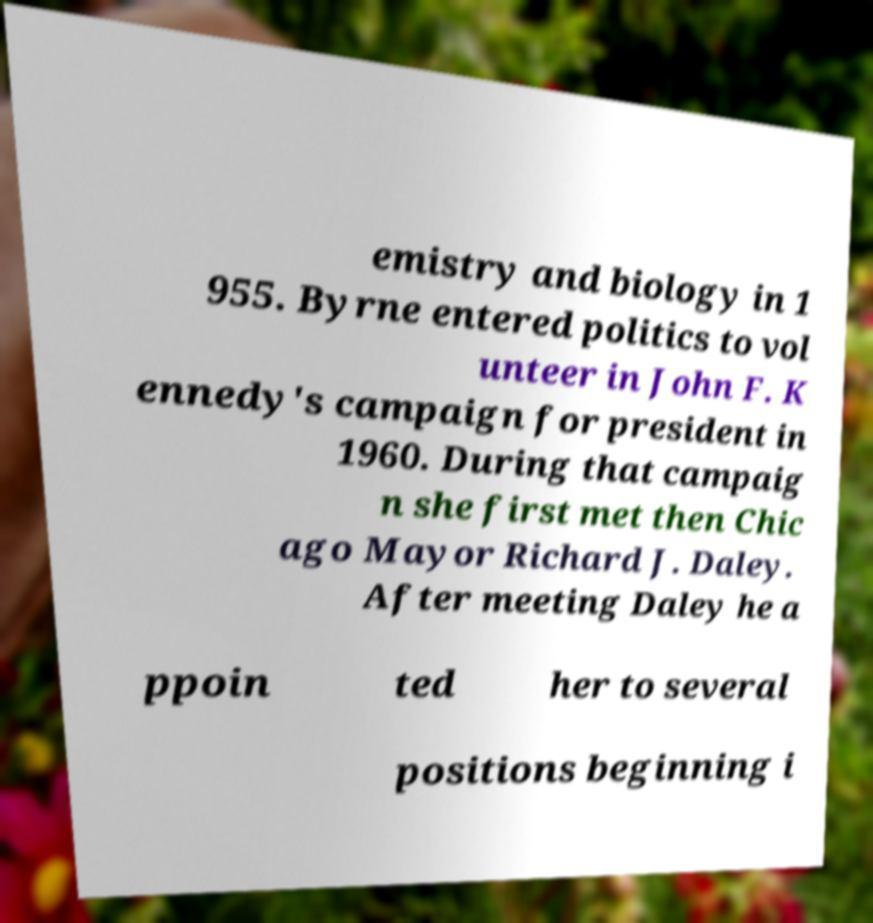Can you accurately transcribe the text from the provided image for me? emistry and biology in 1 955. Byrne entered politics to vol unteer in John F. K ennedy's campaign for president in 1960. During that campaig n she first met then Chic ago Mayor Richard J. Daley. After meeting Daley he a ppoin ted her to several positions beginning i 